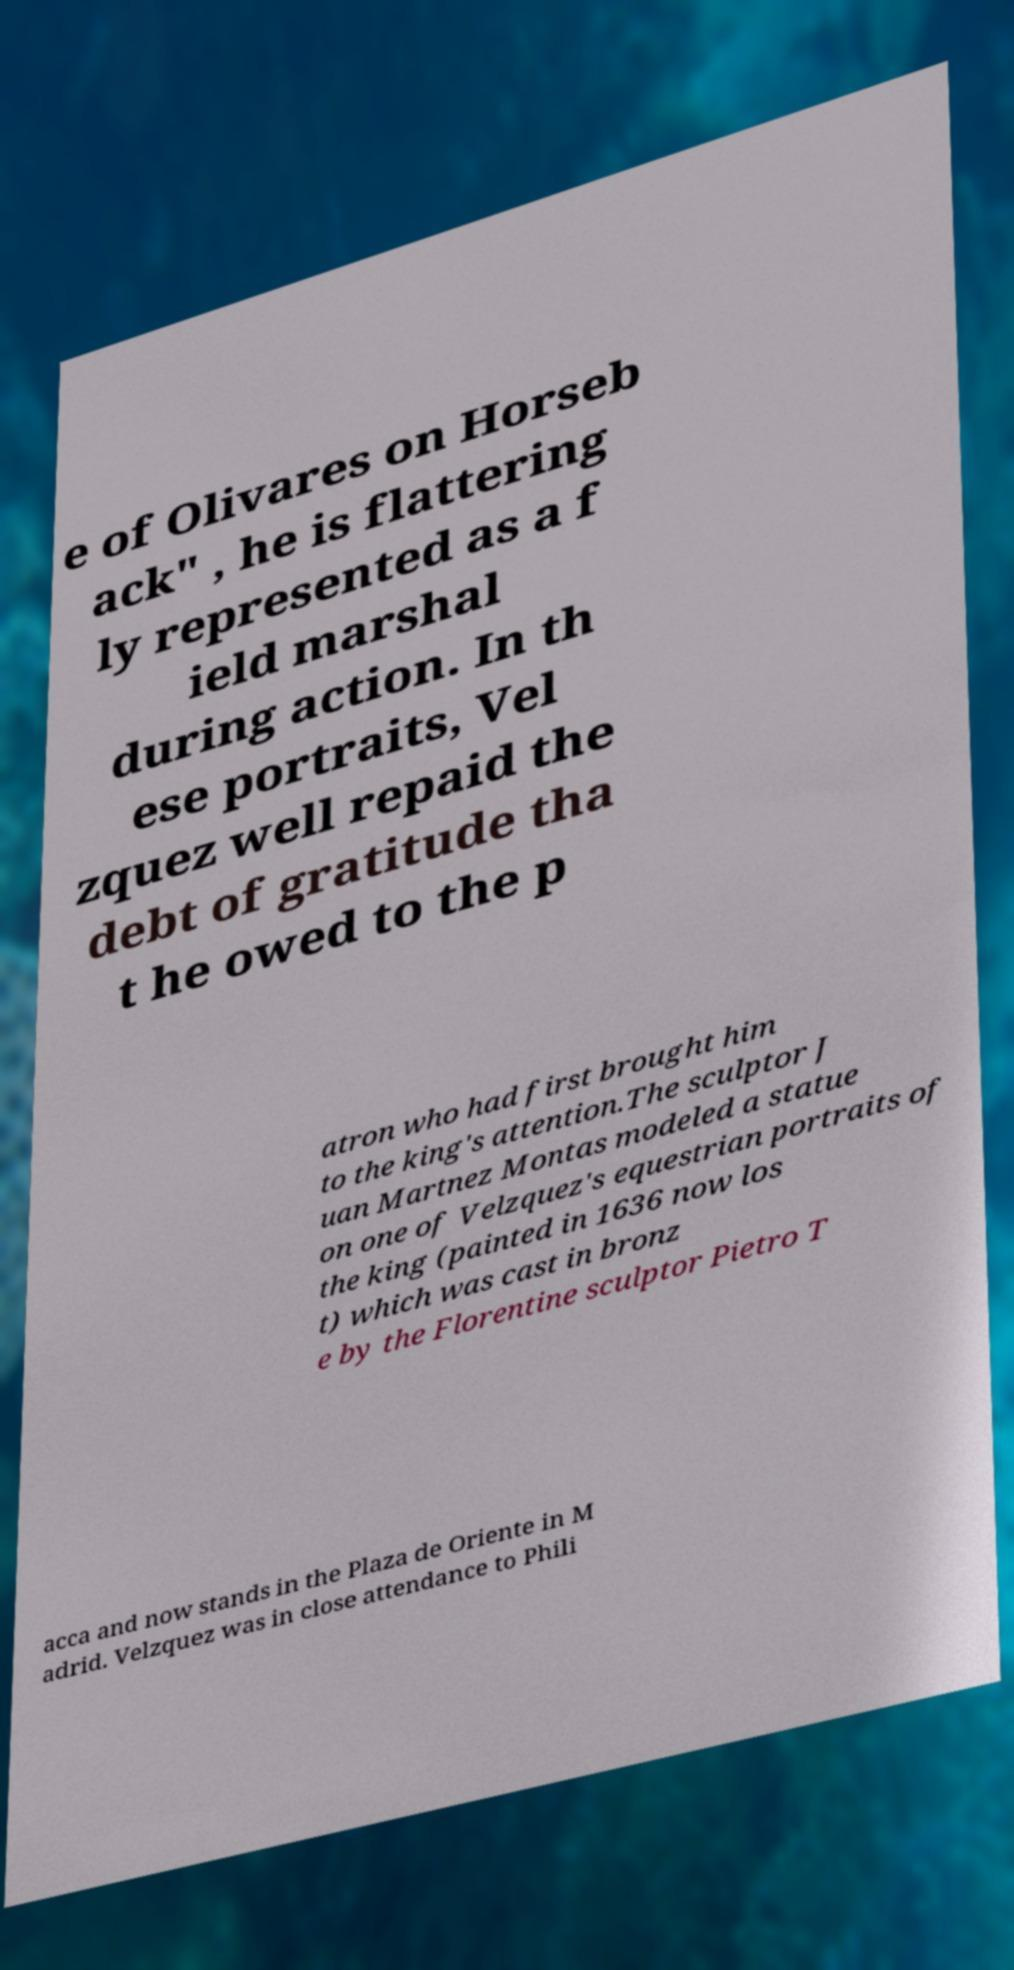Can you read and provide the text displayed in the image?This photo seems to have some interesting text. Can you extract and type it out for me? e of Olivares on Horseb ack" , he is flattering ly represented as a f ield marshal during action. In th ese portraits, Vel zquez well repaid the debt of gratitude tha t he owed to the p atron who had first brought him to the king's attention.The sculptor J uan Martnez Montas modeled a statue on one of Velzquez's equestrian portraits of the king (painted in 1636 now los t) which was cast in bronz e by the Florentine sculptor Pietro T acca and now stands in the Plaza de Oriente in M adrid. Velzquez was in close attendance to Phili 